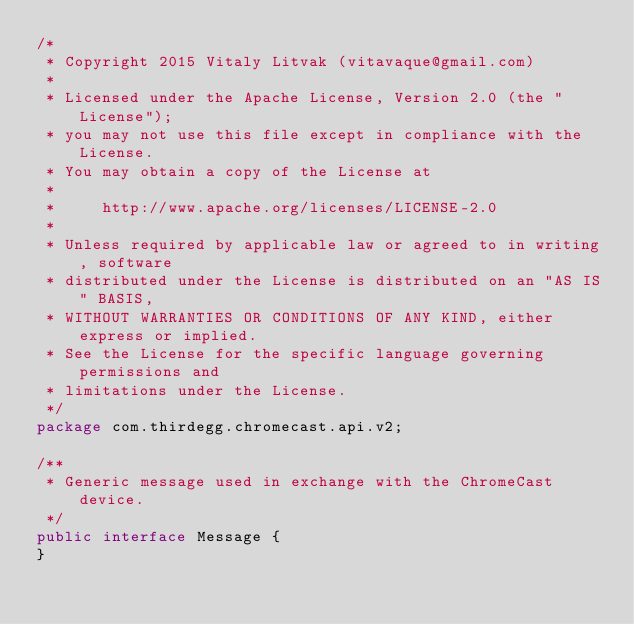<code> <loc_0><loc_0><loc_500><loc_500><_Java_>/*
 * Copyright 2015 Vitaly Litvak (vitavaque@gmail.com)
 *
 * Licensed under the Apache License, Version 2.0 (the "License");
 * you may not use this file except in compliance with the License.
 * You may obtain a copy of the License at
 *
 *     http://www.apache.org/licenses/LICENSE-2.0
 *
 * Unless required by applicable law or agreed to in writing, software
 * distributed under the License is distributed on an "AS IS" BASIS,
 * WITHOUT WARRANTIES OR CONDITIONS OF ANY KIND, either express or implied.
 * See the License for the specific language governing permissions and
 * limitations under the License.
 */
package com.thirdegg.chromecast.api.v2;

/**
 * Generic message used in exchange with the ChromeCast device.
 */
public interface Message {
}
</code> 